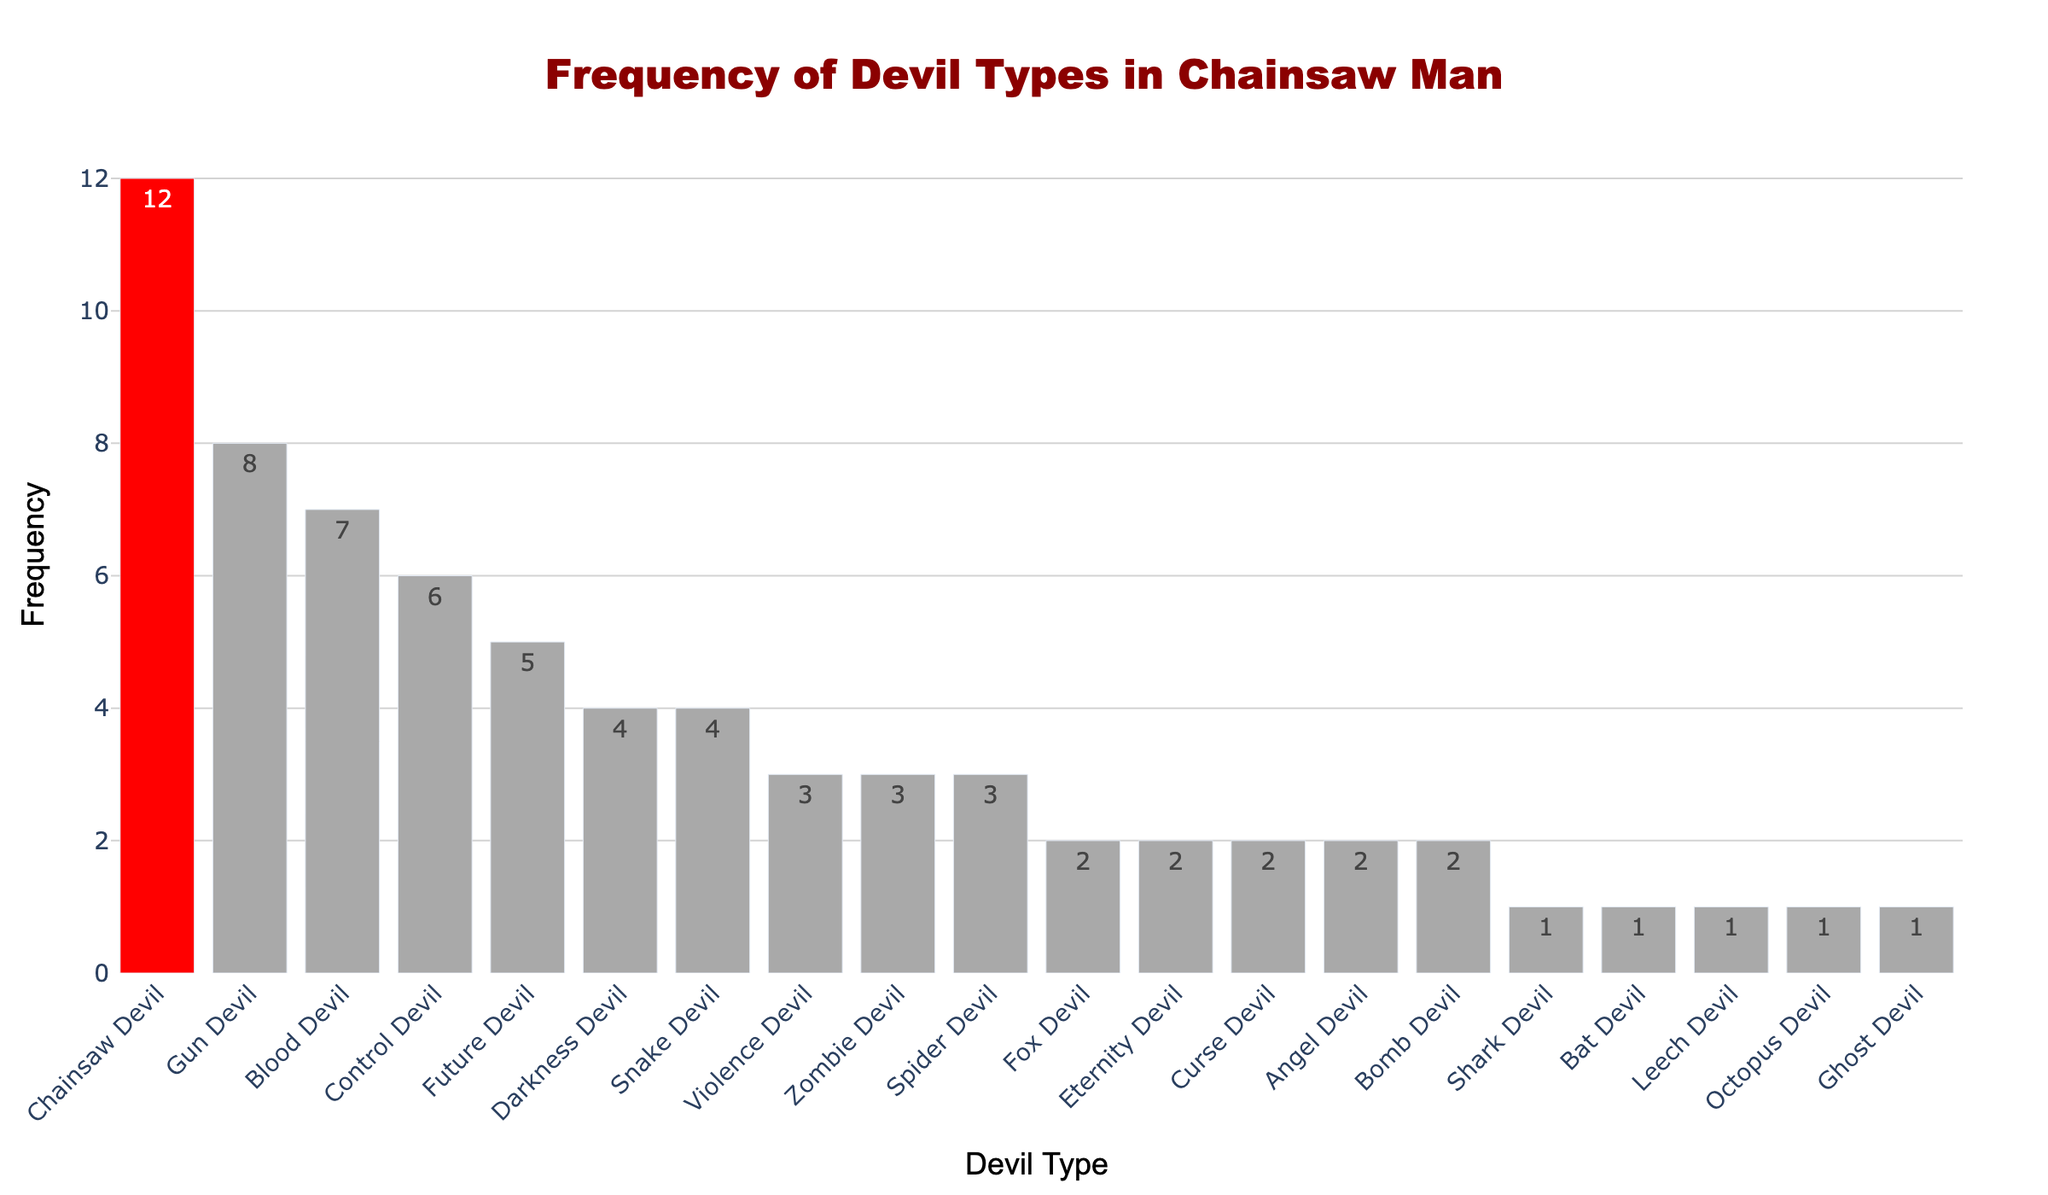Which devil type appears most frequently in the "Chainsaw Man" series? By looking at the heights of the bars and the corresponding labels, we can see that the "Chainsaw Devil" has the tallest bar with a frequency of 12, indicating it appears most frequently.
Answer: Chainsaw Devil Which two devil types have the same frequency and are both the least frequent? From the figure, the "Shark Devil," "Bat Devil," "Leech Devil," "Octopus Devil," and "Ghost Devil" all have the smallest bar with a frequency of 1, indicating they appear the least frequently.
Answer: Shark Devil, Bat Devil, Leech Devil, Octopus Devil, Ghost Devil How many more times does the Chainsaw Devil appear compared to the Gun Devil? The Chainsaw Devil appears 12 times and the Gun Devil appears 8 times. Subtracting 8 from 12 gives us the number of times Chainsaw Devil appears more than Gun Devil: 12 - 8 = 4.
Answer: 4 What is the total frequency of all devil types whose bars have the same height and are labeled with a frequency of 3? The "Violence Devil," "Zombie Devil," and "Spider Devil" all have bars of height 3. Summing up their frequencies gives us: 3 + 3 + 3 = 9.
Answer: 9 Which devil type has a bar colored differently compared to the rest, and what is that color? The bar representing the "Chainsaw Devil" is colored differently from the rest, specifically in red, while the others are dark grey.
Answer: Chainsaw Devil, red What is the total frequency of devils starting with the letter 'B'? The "Blood Devil," "Bomb Devil," "Bat Devil," and "Bird Devil" have frequencies of 7, 2, and 1 respectively. Adding them gives: 7 + 2 + 1 = 10.
Answer: 10 Compare the frequencies of the Control Devil and the Future Devil. Which is higher and by how much? The Control Devil has a frequency of 6, and the Future Devil has a frequency of 5. The Control Devil has a higher frequency by 1.
Answer: Control Devil, 1 What percentage of the total frequency does the Chainsaw Devil account for? First, calculate the total frequency of all devils, which is the sum of all their frequencies: 12 + 8 + 7 + 6 + 5 + 4 + 4 + 3 + 3 + 3 + 2 + 2 + 2 + 2 + 2 + 1 + 1 + 1 + 1 + 1 = 70. The Chainsaw Devil's frequency is 12. The percentage is (12 / 70) * 100 ≈ 17.14%.
Answer: 17.14% What is the combined frequency of the most frequently appearing three devil types? The most frequently appearing devils are "Chainsaw Devil," "Gun Devil," and "Blood Devil" with frequencies of 12, 8, and 7 respectively. Adding these gives: 12 + 8 + 7 = 27.
Answer: 27 